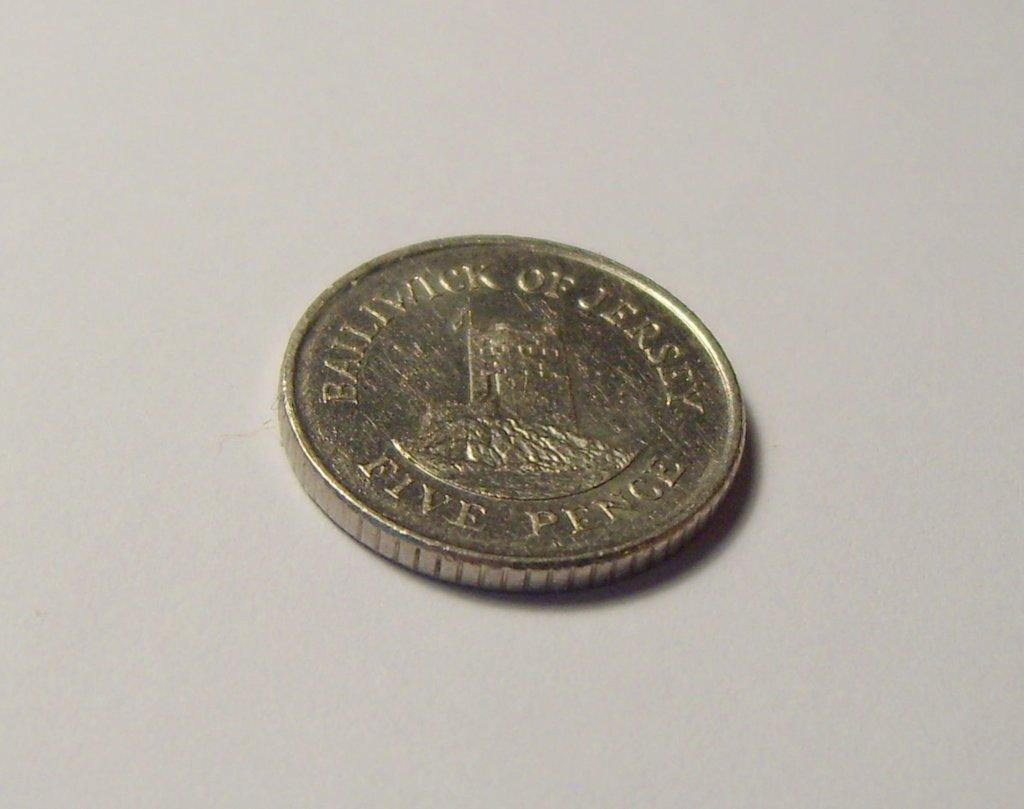Provide a one-sentence caption for the provided image. A round coin on a table that says Balltwtck of Jersey. 